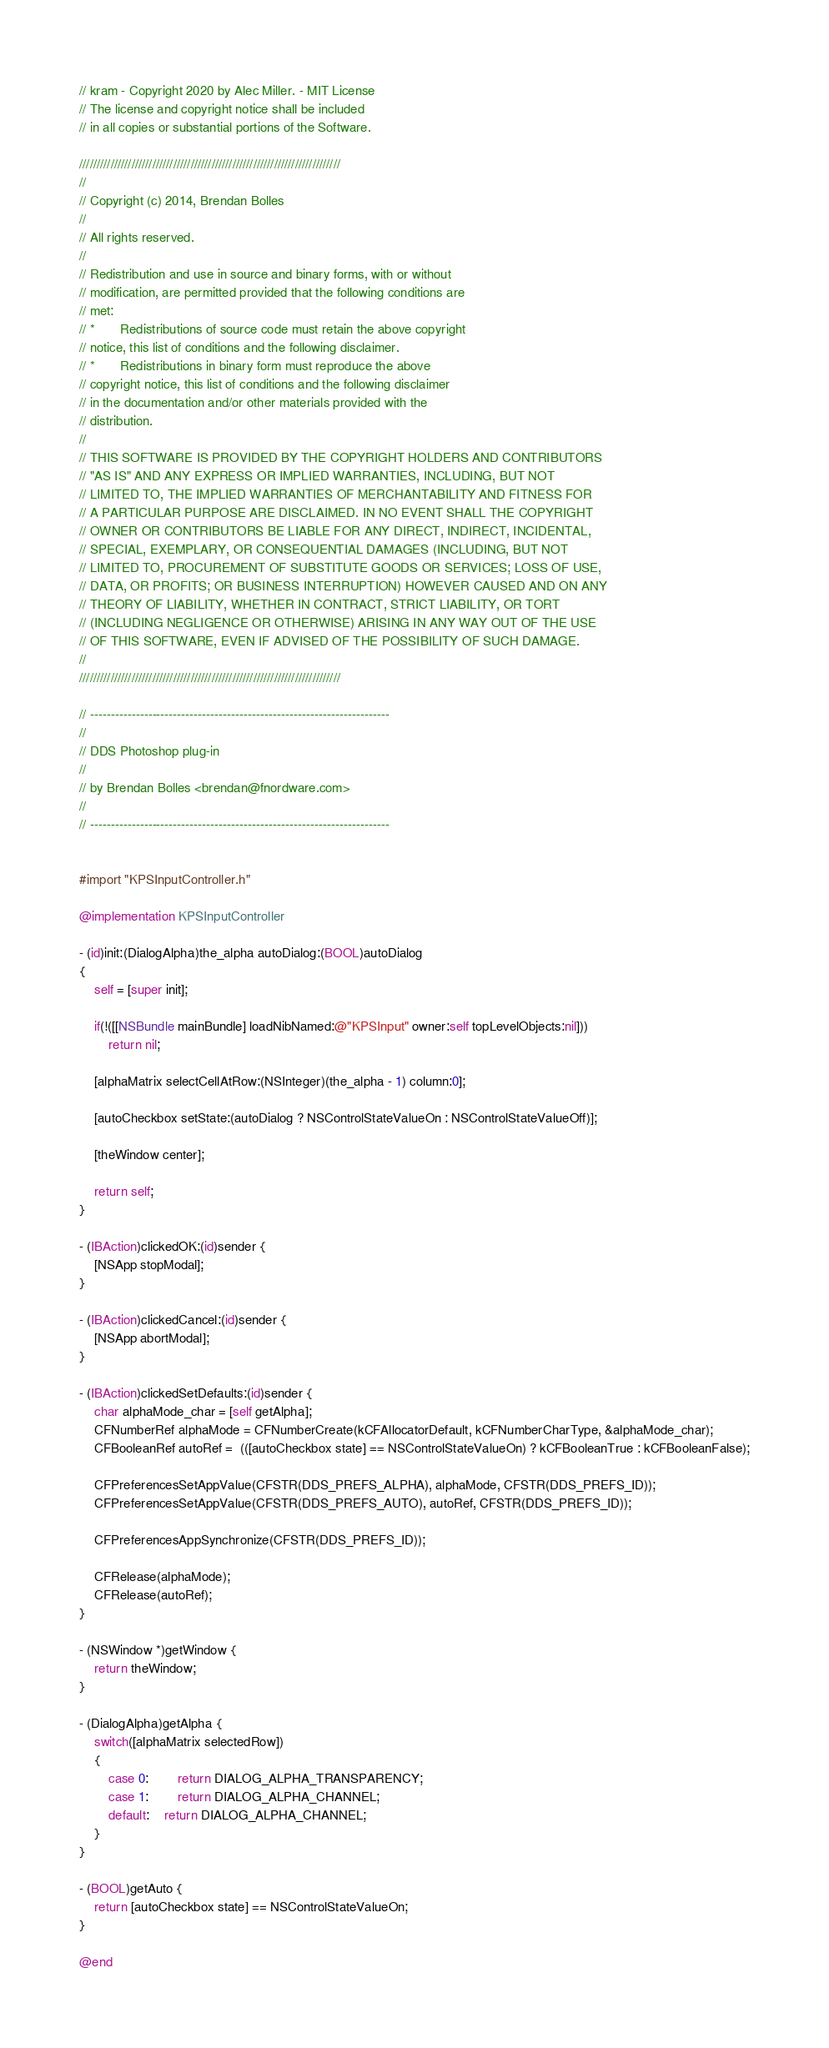Convert code to text. <code><loc_0><loc_0><loc_500><loc_500><_ObjectiveC_>
// kram - Copyright 2020 by Alec Miller. - MIT License
// The license and copyright notice shall be included
// in all copies or substantial portions of the Software.

///////////////////////////////////////////////////////////////////////////
//
// Copyright (c) 2014, Brendan Bolles
//
// All rights reserved.
//
// Redistribution and use in source and binary forms, with or without
// modification, are permitted provided that the following conditions are
// met:
// *	   Redistributions of source code must retain the above copyright
// notice, this list of conditions and the following disclaimer.
// *	   Redistributions in binary form must reproduce the above
// copyright notice, this list of conditions and the following disclaimer
// in the documentation and/or other materials provided with the
// distribution.
//
// THIS SOFTWARE IS PROVIDED BY THE COPYRIGHT HOLDERS AND CONTRIBUTORS
// "AS IS" AND ANY EXPRESS OR IMPLIED WARRANTIES, INCLUDING, BUT NOT
// LIMITED TO, THE IMPLIED WARRANTIES OF MERCHANTABILITY AND FITNESS FOR
// A PARTICULAR PURPOSE ARE DISCLAIMED. IN NO EVENT SHALL THE COPYRIGHT
// OWNER OR CONTRIBUTORS BE LIABLE FOR ANY DIRECT, INDIRECT, INCIDENTAL,
// SPECIAL, EXEMPLARY, OR CONSEQUENTIAL DAMAGES (INCLUDING, BUT NOT
// LIMITED TO, PROCUREMENT OF SUBSTITUTE GOODS OR SERVICES; LOSS OF USE,
// DATA, OR PROFITS; OR BUSINESS INTERRUPTION) HOWEVER CAUSED AND ON ANY
// THEORY OF LIABILITY, WHETHER IN CONTRACT, STRICT LIABILITY, OR TORT
// (INCLUDING NEGLIGENCE OR OTHERWISE) ARISING IN ANY WAY OUT OF THE USE
// OF THIS SOFTWARE, EVEN IF ADVISED OF THE POSSIBILITY OF SUCH DAMAGE.
//
///////////////////////////////////////////////////////////////////////////

// ------------------------------------------------------------------------
//
// DDS Photoshop plug-in
//
// by Brendan Bolles <brendan@fnordware.com>
//
// ------------------------------------------------------------------------


#import "KPSInputController.h"

@implementation KPSInputController

- (id)init:(DialogAlpha)the_alpha autoDialog:(BOOL)autoDialog
{
	self = [super init];
	
    if(!([[NSBundle mainBundle] loadNibNamed:@"KPSInput" owner:self topLevelObjects:nil]))
		return nil;
	
	[alphaMatrix selectCellAtRow:(NSInteger)(the_alpha - 1) column:0];
	
    [autoCheckbox setState:(autoDialog ? NSControlStateValueOn : NSControlStateValueOff)];
	
	[theWindow center];
	
	return self;
}

- (IBAction)clickedOK:(id)sender {
	[NSApp stopModal];
}

- (IBAction)clickedCancel:(id)sender {
    [NSApp abortModal];
}

- (IBAction)clickedSetDefaults:(id)sender {
	char alphaMode_char = [self getAlpha];
	CFNumberRef alphaMode = CFNumberCreate(kCFAllocatorDefault, kCFNumberCharType, &alphaMode_char);
    CFBooleanRef autoRef =  (([autoCheckbox state] == NSControlStateValueOn) ? kCFBooleanTrue : kCFBooleanFalse);
	
	CFPreferencesSetAppValue(CFSTR(DDS_PREFS_ALPHA), alphaMode, CFSTR(DDS_PREFS_ID));
	CFPreferencesSetAppValue(CFSTR(DDS_PREFS_AUTO), autoRef, CFSTR(DDS_PREFS_ID));
	
	CFPreferencesAppSynchronize(CFSTR(DDS_PREFS_ID));
	
	CFRelease(alphaMode);
	CFRelease(autoRef);
}

- (NSWindow *)getWindow {
	return theWindow;
}

- (DialogAlpha)getAlpha {
	switch([alphaMatrix selectedRow])
	{
		case 0:		return DIALOG_ALPHA_TRANSPARENCY;
		case 1:		return DIALOG_ALPHA_CHANNEL;
		default:	return DIALOG_ALPHA_CHANNEL;
	}
}

- (BOOL)getAuto {
    return [autoCheckbox state] == NSControlStateValueOn;
}

@end
</code> 